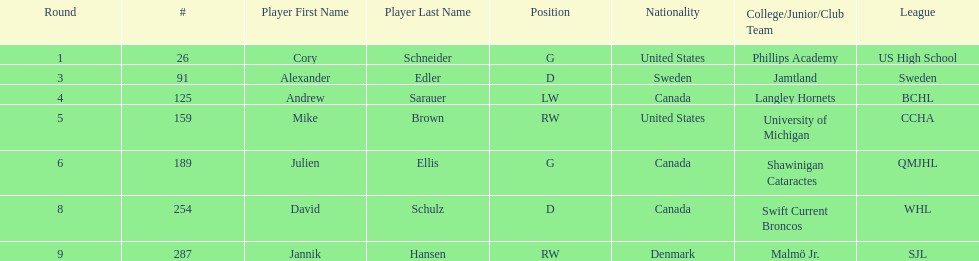Can you parse all the data within this table? {'header': ['Round', '#', 'Player First Name', 'Player Last Name', 'Position', 'Nationality', 'College/Junior/Club Team', 'League'], 'rows': [['1', '26', 'Cory', 'Schneider', 'G', 'United States', 'Phillips Academy', 'US High School'], ['3', '91', 'Alexander', 'Edler', 'D', 'Sweden', 'Jamtland', 'Sweden'], ['4', '125', 'Andrew', 'Sarauer', 'LW', 'Canada', 'Langley Hornets', 'BCHL'], ['5', '159', 'Mike', 'Brown', 'RW', 'United States', 'University of Michigan', 'CCHA'], ['6', '189', 'Julien', 'Ellis', 'G', 'Canada', 'Shawinigan Cataractes', 'QMJHL'], ['8', '254', 'David', 'Schulz', 'D', 'Canada', 'Swift Current Broncos', 'WHL'], ['9', '287', 'Jannik', 'Hansen', 'RW', 'Denmark', 'Malmö Jr.', 'SJL']]} List only the american players. Cory Schneider (G), Mike Brown (RW). 